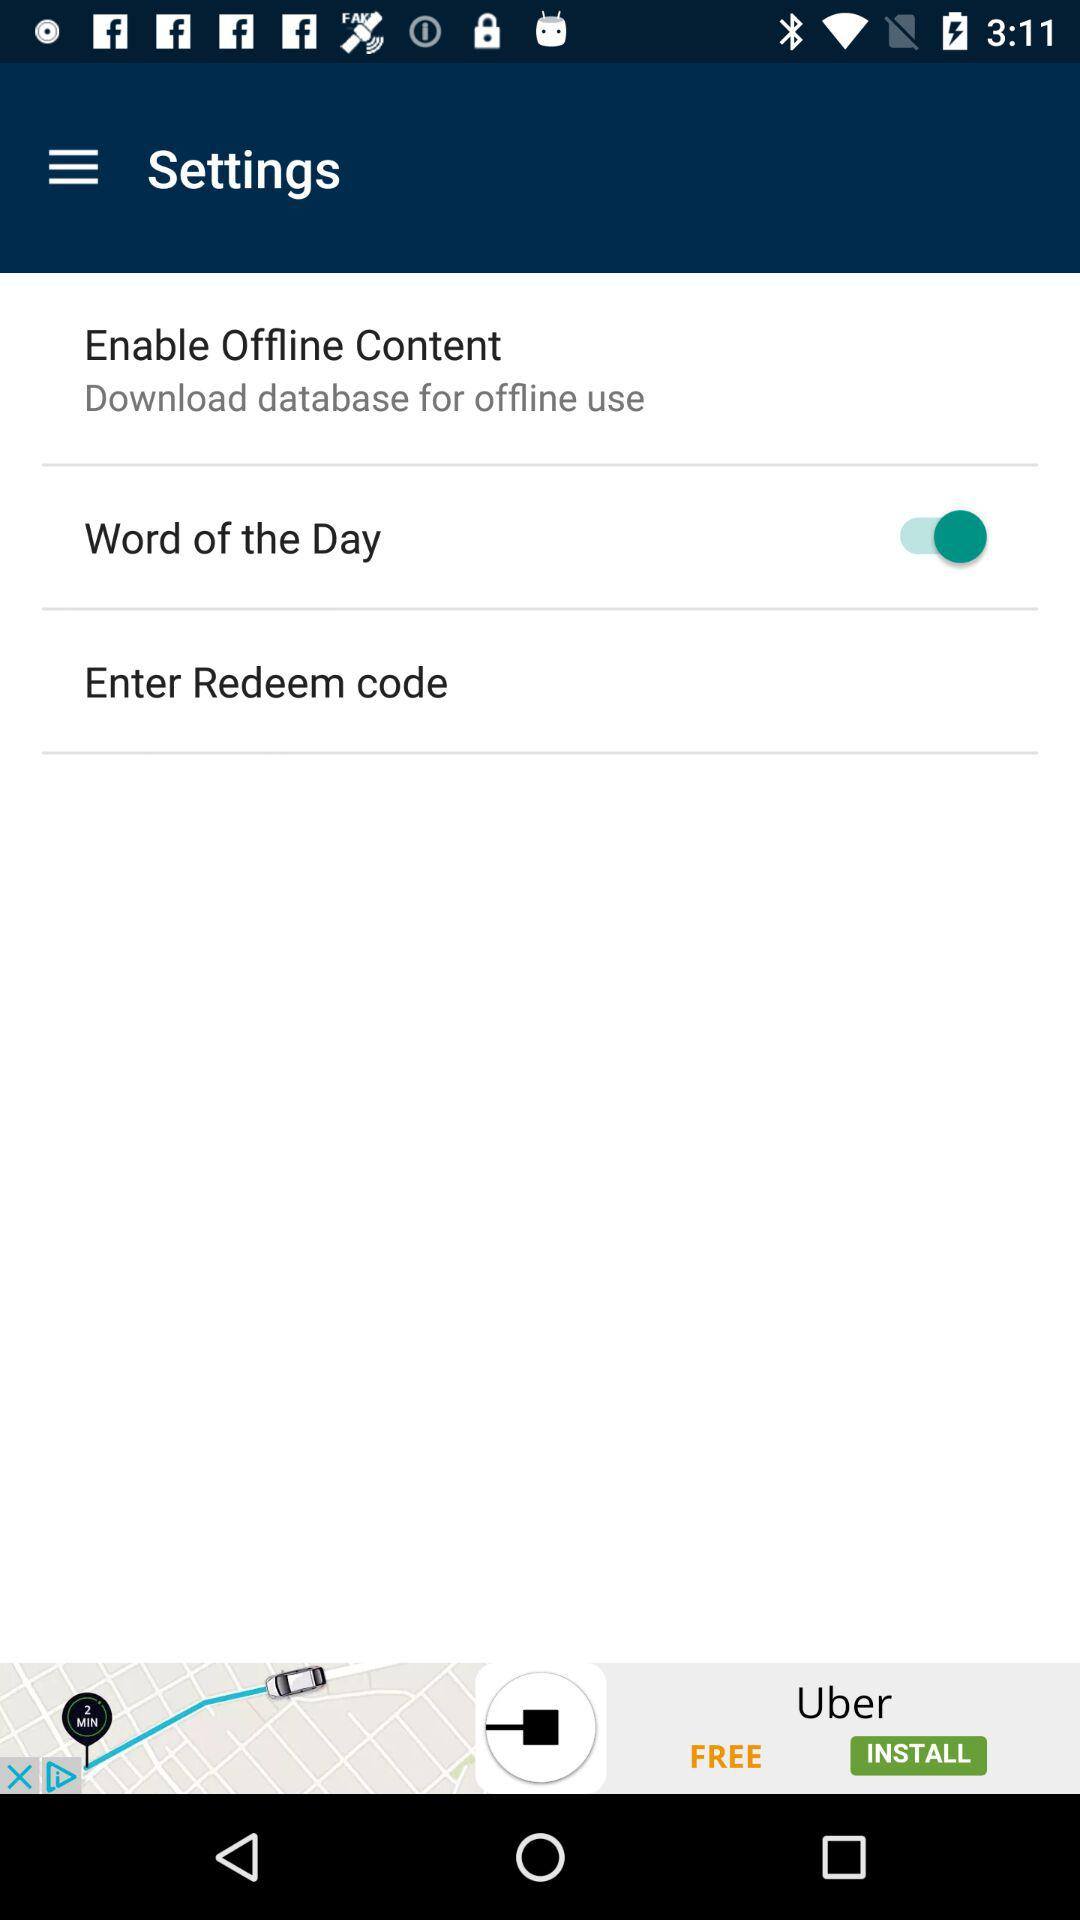What is the description of the "Enable Offline Content"? The description is "Download database for offline use". 